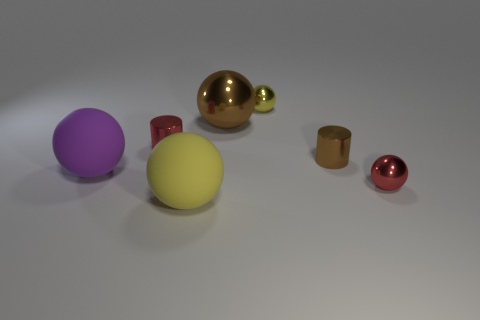What color is the tiny sphere that is in front of the tiny shiny ball that is on the left side of the small shiny cylinder that is right of the small yellow object?
Your response must be concise. Red. Do the cylinder that is to the right of the large metal object and the big shiny ball have the same color?
Your answer should be compact. Yes. What number of other objects are there of the same color as the big shiny sphere?
Your answer should be compact. 1. What number of things are small gray matte cylinders or large things?
Make the answer very short. 3. What number of objects are big purple rubber objects or shiny objects that are left of the brown ball?
Offer a very short reply. 2. Is the material of the purple ball the same as the tiny yellow thing?
Offer a very short reply. No. How many other things are there of the same material as the small red cylinder?
Offer a very short reply. 4. Are there more large spheres than small brown cylinders?
Your response must be concise. Yes. Is the shape of the brown metal object that is to the left of the yellow metal thing the same as  the tiny brown thing?
Offer a terse response. No. Is the number of red metal things less than the number of tiny things?
Ensure brevity in your answer.  Yes. 